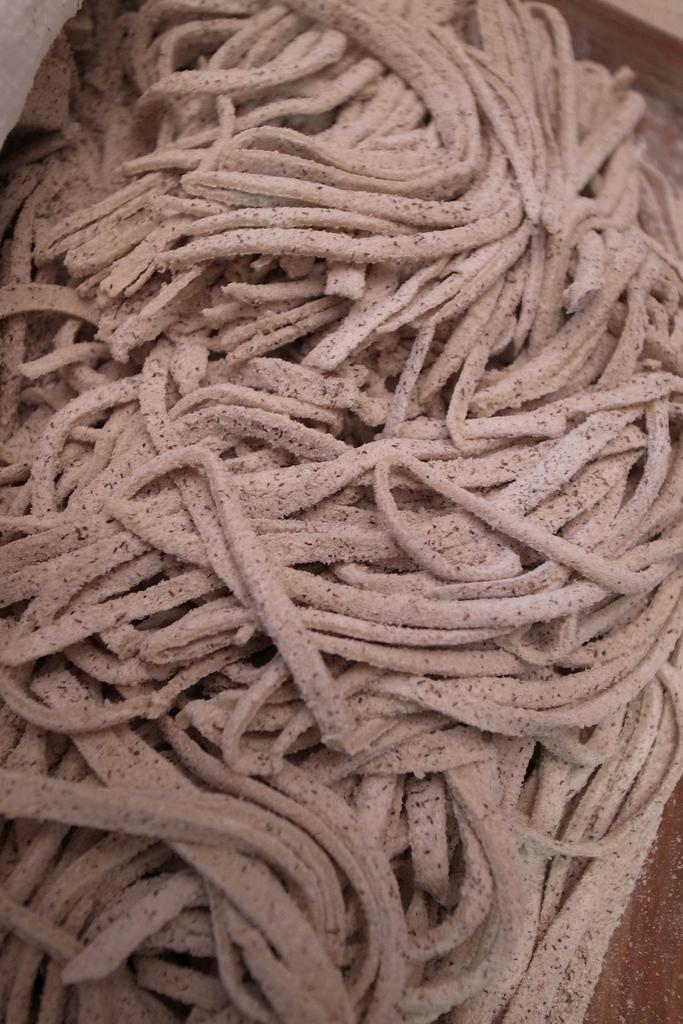Can you describe this image briefly? In the image there is a pile of flour strands on a table. 